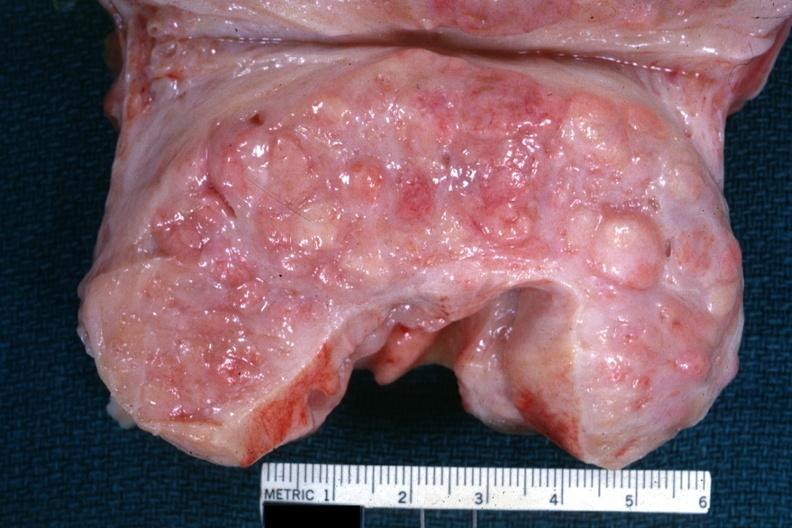s hyperplasia present?
Answer the question using a single word or phrase. Yes 